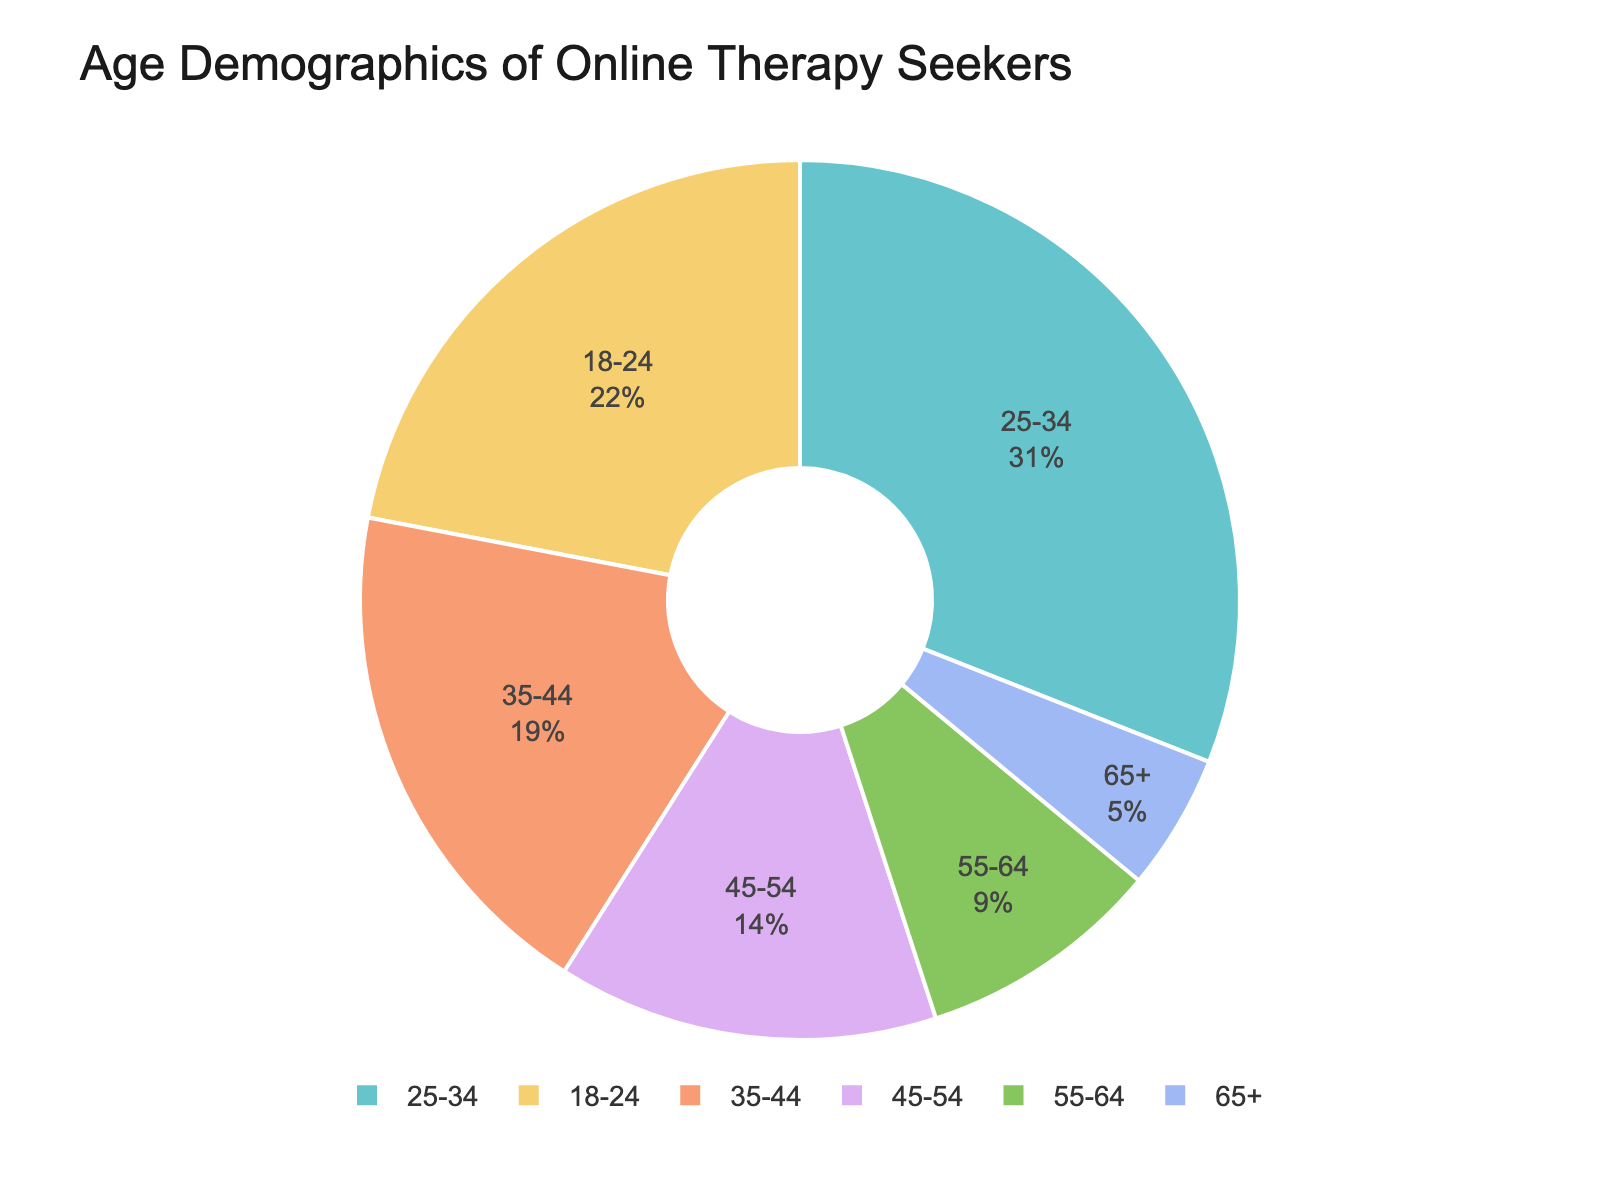What age group represents the largest percentage of online therapy seekers? The age group with the largest slice of the pie chart is 25-34, which is clearly the largest segment in the chart.
Answer: 25-34 What is the combined percentage of therapy seekers aged 35-44 and 45-54? The percentage for 35-44 is 19%, and for 45-54 is 14%. Summing them up: 19% + 14% = 33%.
Answer: 33% Which age group has the smallest representation in the pie chart? The smallest slice of the pie chart is labeled 65+, which represents the smallest percentage of online therapy seekers.
Answer: 65+ How does the percentage of therapy seekers aged 18-24 compare to those aged 55-64? The percentage for 18-24 is 22%, and for 55-64 it is 9%. The comparison shows that 18-24 has a higher percentage of therapy seekers than 55-64.
Answer: 18-24 is greater than 55-64 What is the difference in percentage between the 25-34 age group and the 55-64 age group? The percentage for 25-34 is 31%, and for 55-64 it is 9%. Subtracting the two gives 31% - 9% = 22%.
Answer: 22% What proportion of therapy seekers are aged 45 and above? Adding the percentages for age groups 45-54, 55-64, and 65+: 14% + 9% + 5% = 28%.
Answer: 28% How does the percentage of therapy seekers aged 35-44 compare to the combined percentage of 55-64 and 65+? The percentage for 35-44 is 19%. The combined percentage for 55-64 and 65+ is 9% + 5% = 14%. Comparing the two, 35-44 is greater than the combined 55-64 and 65+.
Answer: 35-44 is greater than combined 55-64 and 65+ What is the percentage difference between the age groups 18-24 and 45-54? The percentage for 18-24 is 22%, and for 45-54 it is 14%. The difference is 22% - 14% = 8%.
Answer: 8% Which age groups together makeup over half of the total demographic? Adding the largest three segments in percentages: 25-34 (31%) + 18-24 (22%) + 35-44 (19%) = 72%, which is more than 50%.
Answer: 18-24, 25-34, 35-44 